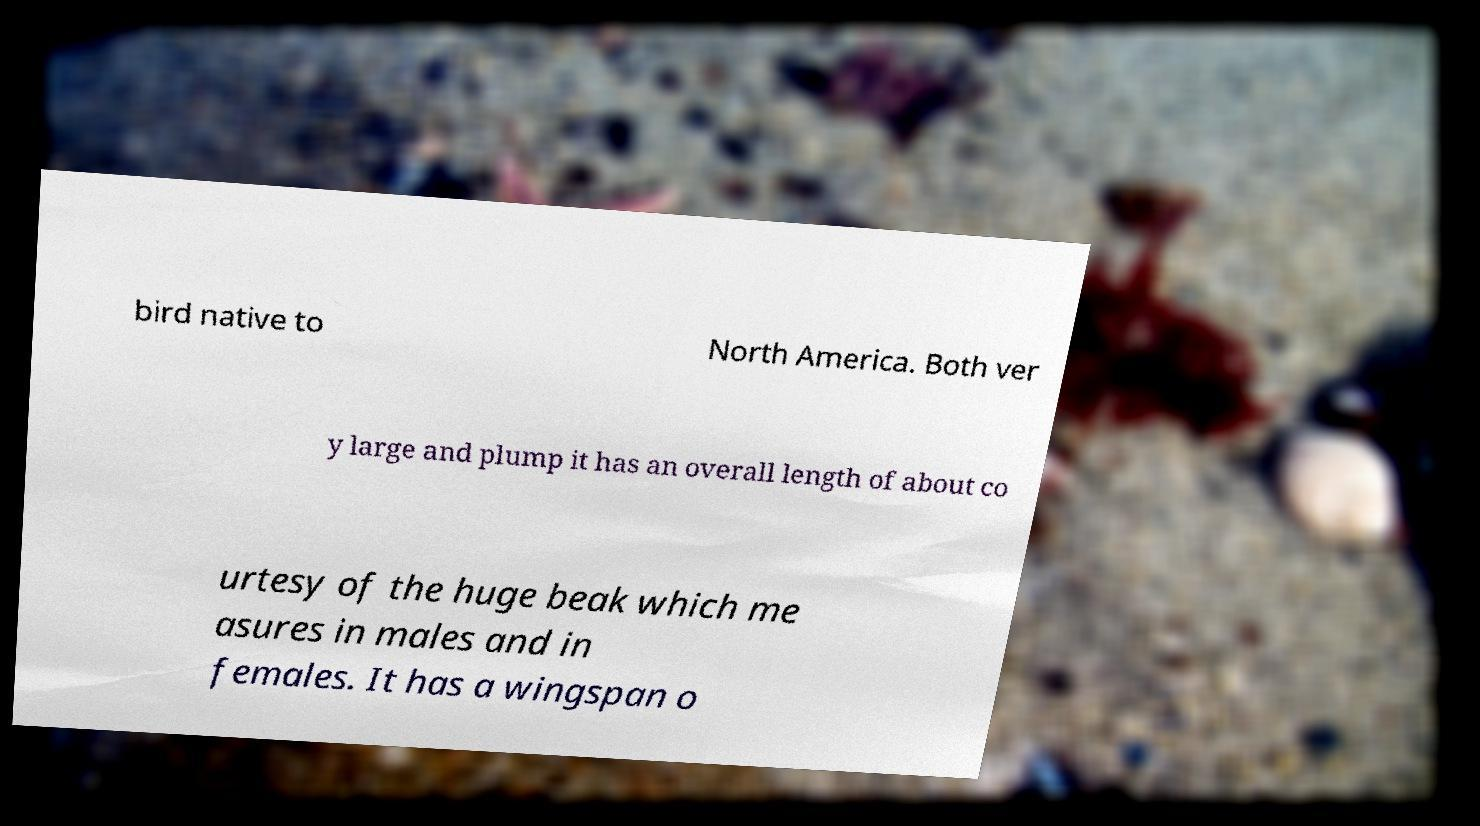What messages or text are displayed in this image? I need them in a readable, typed format. bird native to North America. Both ver y large and plump it has an overall length of about co urtesy of the huge beak which me asures in males and in females. It has a wingspan o 